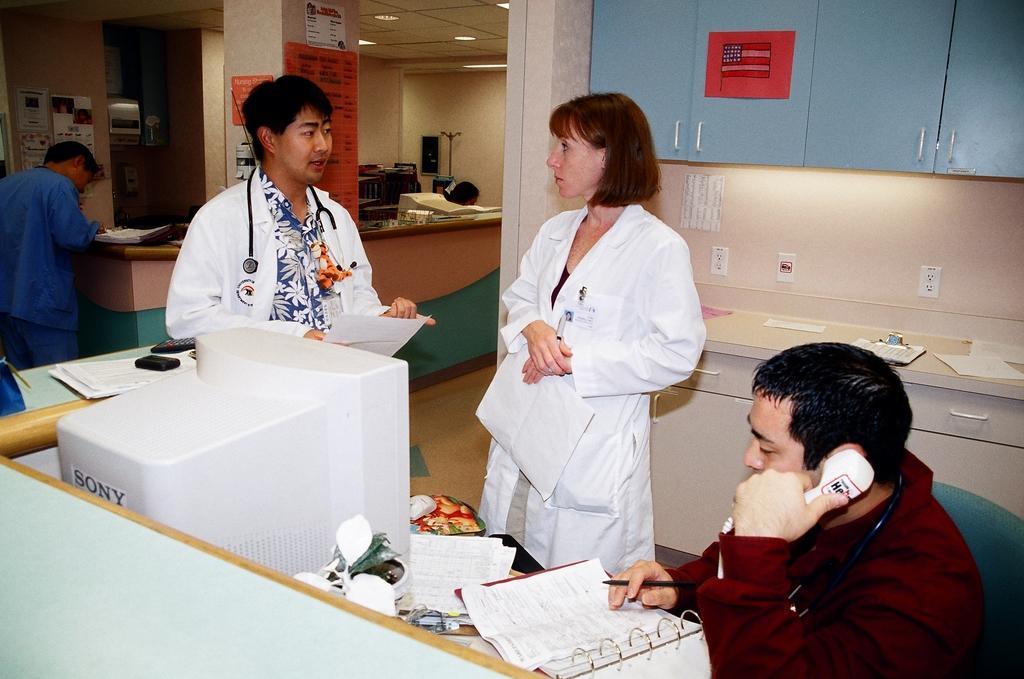How would you summarize this image in a sentence or two? In this image we can see some persons standing on the floor and some are sitting on the chairs, cup boards, electric lights, desktops, telephone, remotes, books, decor plants and electric boards. 